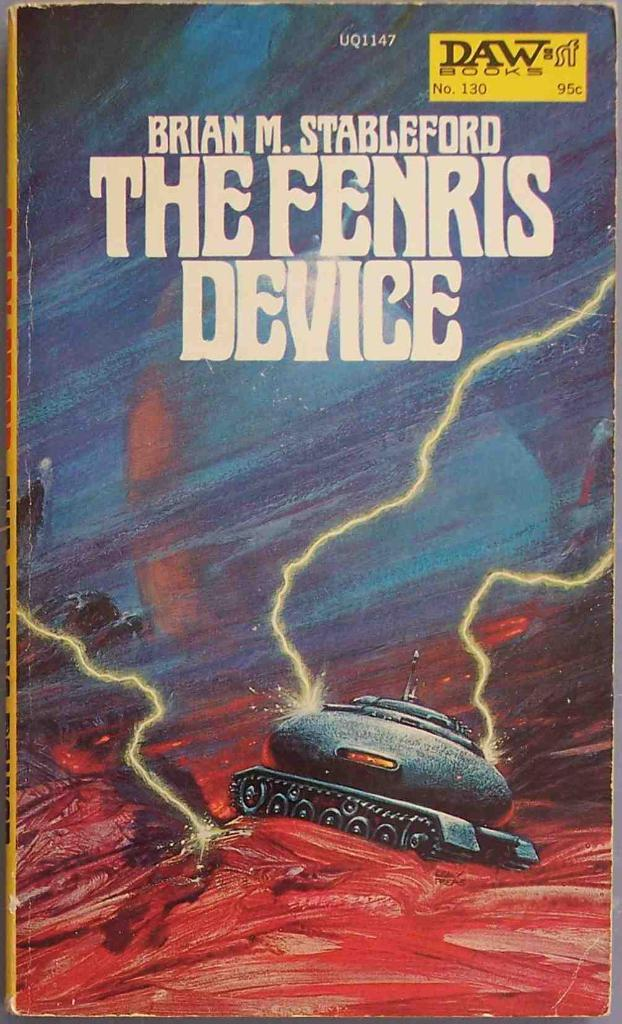Provide a one-sentence caption for the provided image. a copy of the book The fenris device written by brian m. stableford. 